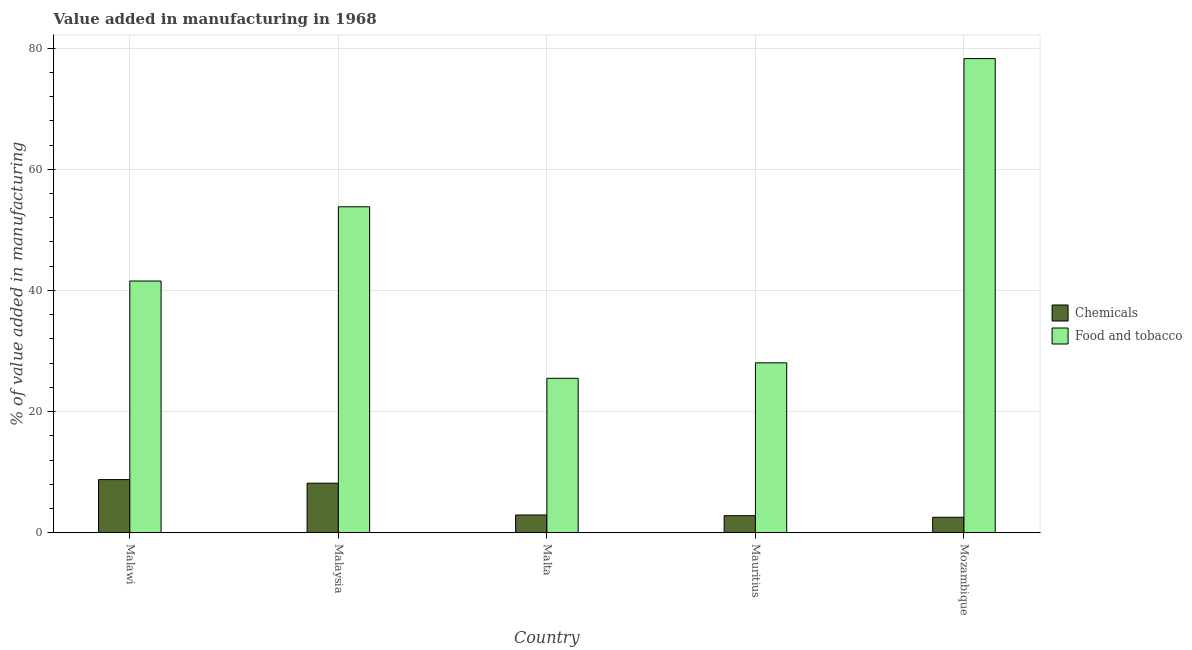How many different coloured bars are there?
Offer a very short reply. 2. What is the label of the 4th group of bars from the left?
Keep it short and to the point. Mauritius. In how many cases, is the number of bars for a given country not equal to the number of legend labels?
Your answer should be very brief. 0. What is the value added by manufacturing food and tobacco in Mauritius?
Your response must be concise. 28.05. Across all countries, what is the maximum value added by  manufacturing chemicals?
Offer a very short reply. 8.77. Across all countries, what is the minimum value added by manufacturing food and tobacco?
Give a very brief answer. 25.49. In which country was the value added by  manufacturing chemicals maximum?
Make the answer very short. Malawi. In which country was the value added by  manufacturing chemicals minimum?
Your response must be concise. Mozambique. What is the total value added by manufacturing food and tobacco in the graph?
Give a very brief answer. 227.2. What is the difference between the value added by  manufacturing chemicals in Malaysia and that in Mozambique?
Provide a succinct answer. 5.63. What is the difference between the value added by  manufacturing chemicals in Malaysia and the value added by manufacturing food and tobacco in Mozambique?
Make the answer very short. -70.11. What is the average value added by  manufacturing chemicals per country?
Your answer should be compact. 5.05. What is the difference between the value added by  manufacturing chemicals and value added by manufacturing food and tobacco in Malawi?
Offer a very short reply. -32.79. What is the ratio of the value added by  manufacturing chemicals in Malaysia to that in Mauritius?
Your response must be concise. 2.91. What is the difference between the highest and the second highest value added by  manufacturing chemicals?
Offer a very short reply. 0.59. What is the difference between the highest and the lowest value added by manufacturing food and tobacco?
Make the answer very short. 52.79. In how many countries, is the value added by manufacturing food and tobacco greater than the average value added by manufacturing food and tobacco taken over all countries?
Your response must be concise. 2. Is the sum of the value added by  manufacturing chemicals in Malaysia and Malta greater than the maximum value added by manufacturing food and tobacco across all countries?
Provide a short and direct response. No. What does the 1st bar from the left in Malaysia represents?
Provide a succinct answer. Chemicals. What does the 1st bar from the right in Mozambique represents?
Make the answer very short. Food and tobacco. How many countries are there in the graph?
Ensure brevity in your answer.  5. Does the graph contain grids?
Offer a very short reply. Yes. Where does the legend appear in the graph?
Provide a succinct answer. Center right. How many legend labels are there?
Keep it short and to the point. 2. How are the legend labels stacked?
Ensure brevity in your answer.  Vertical. What is the title of the graph?
Ensure brevity in your answer.  Value added in manufacturing in 1968. What is the label or title of the X-axis?
Ensure brevity in your answer.  Country. What is the label or title of the Y-axis?
Provide a succinct answer. % of value added in manufacturing. What is the % of value added in manufacturing in Chemicals in Malawi?
Keep it short and to the point. 8.77. What is the % of value added in manufacturing in Food and tobacco in Malawi?
Provide a short and direct response. 41.56. What is the % of value added in manufacturing of Chemicals in Malaysia?
Your answer should be compact. 8.18. What is the % of value added in manufacturing of Food and tobacco in Malaysia?
Ensure brevity in your answer.  53.82. What is the % of value added in manufacturing of Chemicals in Malta?
Provide a succinct answer. 2.93. What is the % of value added in manufacturing in Food and tobacco in Malta?
Keep it short and to the point. 25.49. What is the % of value added in manufacturing in Chemicals in Mauritius?
Provide a succinct answer. 2.81. What is the % of value added in manufacturing of Food and tobacco in Mauritius?
Provide a short and direct response. 28.05. What is the % of value added in manufacturing of Chemicals in Mozambique?
Make the answer very short. 2.55. What is the % of value added in manufacturing in Food and tobacco in Mozambique?
Your answer should be very brief. 78.28. Across all countries, what is the maximum % of value added in manufacturing in Chemicals?
Offer a very short reply. 8.77. Across all countries, what is the maximum % of value added in manufacturing in Food and tobacco?
Make the answer very short. 78.28. Across all countries, what is the minimum % of value added in manufacturing of Chemicals?
Offer a terse response. 2.55. Across all countries, what is the minimum % of value added in manufacturing in Food and tobacco?
Ensure brevity in your answer.  25.49. What is the total % of value added in manufacturing of Chemicals in the graph?
Your response must be concise. 25.24. What is the total % of value added in manufacturing of Food and tobacco in the graph?
Offer a very short reply. 227.2. What is the difference between the % of value added in manufacturing in Chemicals in Malawi and that in Malaysia?
Offer a terse response. 0.59. What is the difference between the % of value added in manufacturing in Food and tobacco in Malawi and that in Malaysia?
Provide a succinct answer. -12.26. What is the difference between the % of value added in manufacturing in Chemicals in Malawi and that in Malta?
Ensure brevity in your answer.  5.84. What is the difference between the % of value added in manufacturing of Food and tobacco in Malawi and that in Malta?
Your response must be concise. 16.06. What is the difference between the % of value added in manufacturing in Chemicals in Malawi and that in Mauritius?
Provide a succinct answer. 5.96. What is the difference between the % of value added in manufacturing in Food and tobacco in Malawi and that in Mauritius?
Provide a short and direct response. 13.51. What is the difference between the % of value added in manufacturing in Chemicals in Malawi and that in Mozambique?
Your answer should be very brief. 6.22. What is the difference between the % of value added in manufacturing of Food and tobacco in Malawi and that in Mozambique?
Provide a succinct answer. -36.73. What is the difference between the % of value added in manufacturing of Chemicals in Malaysia and that in Malta?
Your answer should be very brief. 5.25. What is the difference between the % of value added in manufacturing in Food and tobacco in Malaysia and that in Malta?
Offer a very short reply. 28.32. What is the difference between the % of value added in manufacturing in Chemicals in Malaysia and that in Mauritius?
Your answer should be very brief. 5.37. What is the difference between the % of value added in manufacturing in Food and tobacco in Malaysia and that in Mauritius?
Your answer should be compact. 25.77. What is the difference between the % of value added in manufacturing in Chemicals in Malaysia and that in Mozambique?
Keep it short and to the point. 5.63. What is the difference between the % of value added in manufacturing of Food and tobacco in Malaysia and that in Mozambique?
Your response must be concise. -24.47. What is the difference between the % of value added in manufacturing of Chemicals in Malta and that in Mauritius?
Offer a terse response. 0.12. What is the difference between the % of value added in manufacturing in Food and tobacco in Malta and that in Mauritius?
Provide a succinct answer. -2.55. What is the difference between the % of value added in manufacturing in Chemicals in Malta and that in Mozambique?
Give a very brief answer. 0.38. What is the difference between the % of value added in manufacturing of Food and tobacco in Malta and that in Mozambique?
Ensure brevity in your answer.  -52.79. What is the difference between the % of value added in manufacturing in Chemicals in Mauritius and that in Mozambique?
Make the answer very short. 0.26. What is the difference between the % of value added in manufacturing of Food and tobacco in Mauritius and that in Mozambique?
Make the answer very short. -50.24. What is the difference between the % of value added in manufacturing in Chemicals in Malawi and the % of value added in manufacturing in Food and tobacco in Malaysia?
Provide a short and direct response. -45.05. What is the difference between the % of value added in manufacturing in Chemicals in Malawi and the % of value added in manufacturing in Food and tobacco in Malta?
Offer a terse response. -16.73. What is the difference between the % of value added in manufacturing of Chemicals in Malawi and the % of value added in manufacturing of Food and tobacco in Mauritius?
Your answer should be very brief. -19.28. What is the difference between the % of value added in manufacturing of Chemicals in Malawi and the % of value added in manufacturing of Food and tobacco in Mozambique?
Your answer should be compact. -69.52. What is the difference between the % of value added in manufacturing of Chemicals in Malaysia and the % of value added in manufacturing of Food and tobacco in Malta?
Offer a terse response. -17.32. What is the difference between the % of value added in manufacturing in Chemicals in Malaysia and the % of value added in manufacturing in Food and tobacco in Mauritius?
Ensure brevity in your answer.  -19.87. What is the difference between the % of value added in manufacturing of Chemicals in Malaysia and the % of value added in manufacturing of Food and tobacco in Mozambique?
Provide a short and direct response. -70.11. What is the difference between the % of value added in manufacturing of Chemicals in Malta and the % of value added in manufacturing of Food and tobacco in Mauritius?
Make the answer very short. -25.12. What is the difference between the % of value added in manufacturing in Chemicals in Malta and the % of value added in manufacturing in Food and tobacco in Mozambique?
Make the answer very short. -75.36. What is the difference between the % of value added in manufacturing of Chemicals in Mauritius and the % of value added in manufacturing of Food and tobacco in Mozambique?
Your answer should be compact. -75.47. What is the average % of value added in manufacturing of Chemicals per country?
Offer a terse response. 5.05. What is the average % of value added in manufacturing of Food and tobacco per country?
Your answer should be very brief. 45.44. What is the difference between the % of value added in manufacturing of Chemicals and % of value added in manufacturing of Food and tobacco in Malawi?
Make the answer very short. -32.79. What is the difference between the % of value added in manufacturing in Chemicals and % of value added in manufacturing in Food and tobacco in Malaysia?
Make the answer very short. -45.64. What is the difference between the % of value added in manufacturing in Chemicals and % of value added in manufacturing in Food and tobacco in Malta?
Make the answer very short. -22.57. What is the difference between the % of value added in manufacturing in Chemicals and % of value added in manufacturing in Food and tobacco in Mauritius?
Ensure brevity in your answer.  -25.24. What is the difference between the % of value added in manufacturing of Chemicals and % of value added in manufacturing of Food and tobacco in Mozambique?
Offer a terse response. -75.73. What is the ratio of the % of value added in manufacturing in Chemicals in Malawi to that in Malaysia?
Your answer should be very brief. 1.07. What is the ratio of the % of value added in manufacturing in Food and tobacco in Malawi to that in Malaysia?
Your answer should be compact. 0.77. What is the ratio of the % of value added in manufacturing in Chemicals in Malawi to that in Malta?
Make the answer very short. 2.99. What is the ratio of the % of value added in manufacturing of Food and tobacco in Malawi to that in Malta?
Your response must be concise. 1.63. What is the ratio of the % of value added in manufacturing in Chemicals in Malawi to that in Mauritius?
Provide a succinct answer. 3.12. What is the ratio of the % of value added in manufacturing of Food and tobacco in Malawi to that in Mauritius?
Your answer should be very brief. 1.48. What is the ratio of the % of value added in manufacturing in Chemicals in Malawi to that in Mozambique?
Make the answer very short. 3.44. What is the ratio of the % of value added in manufacturing of Food and tobacco in Malawi to that in Mozambique?
Give a very brief answer. 0.53. What is the ratio of the % of value added in manufacturing of Chemicals in Malaysia to that in Malta?
Provide a short and direct response. 2.79. What is the ratio of the % of value added in manufacturing of Food and tobacco in Malaysia to that in Malta?
Your answer should be very brief. 2.11. What is the ratio of the % of value added in manufacturing in Chemicals in Malaysia to that in Mauritius?
Make the answer very short. 2.91. What is the ratio of the % of value added in manufacturing in Food and tobacco in Malaysia to that in Mauritius?
Give a very brief answer. 1.92. What is the ratio of the % of value added in manufacturing of Chemicals in Malaysia to that in Mozambique?
Provide a succinct answer. 3.21. What is the ratio of the % of value added in manufacturing of Food and tobacco in Malaysia to that in Mozambique?
Provide a succinct answer. 0.69. What is the ratio of the % of value added in manufacturing of Chemicals in Malta to that in Mauritius?
Offer a terse response. 1.04. What is the ratio of the % of value added in manufacturing of Food and tobacco in Malta to that in Mauritius?
Provide a short and direct response. 0.91. What is the ratio of the % of value added in manufacturing of Chemicals in Malta to that in Mozambique?
Your answer should be very brief. 1.15. What is the ratio of the % of value added in manufacturing of Food and tobacco in Malta to that in Mozambique?
Make the answer very short. 0.33. What is the ratio of the % of value added in manufacturing in Chemicals in Mauritius to that in Mozambique?
Your answer should be very brief. 1.1. What is the ratio of the % of value added in manufacturing in Food and tobacco in Mauritius to that in Mozambique?
Offer a very short reply. 0.36. What is the difference between the highest and the second highest % of value added in manufacturing in Chemicals?
Offer a terse response. 0.59. What is the difference between the highest and the second highest % of value added in manufacturing of Food and tobacco?
Your response must be concise. 24.47. What is the difference between the highest and the lowest % of value added in manufacturing in Chemicals?
Offer a very short reply. 6.22. What is the difference between the highest and the lowest % of value added in manufacturing in Food and tobacco?
Your response must be concise. 52.79. 